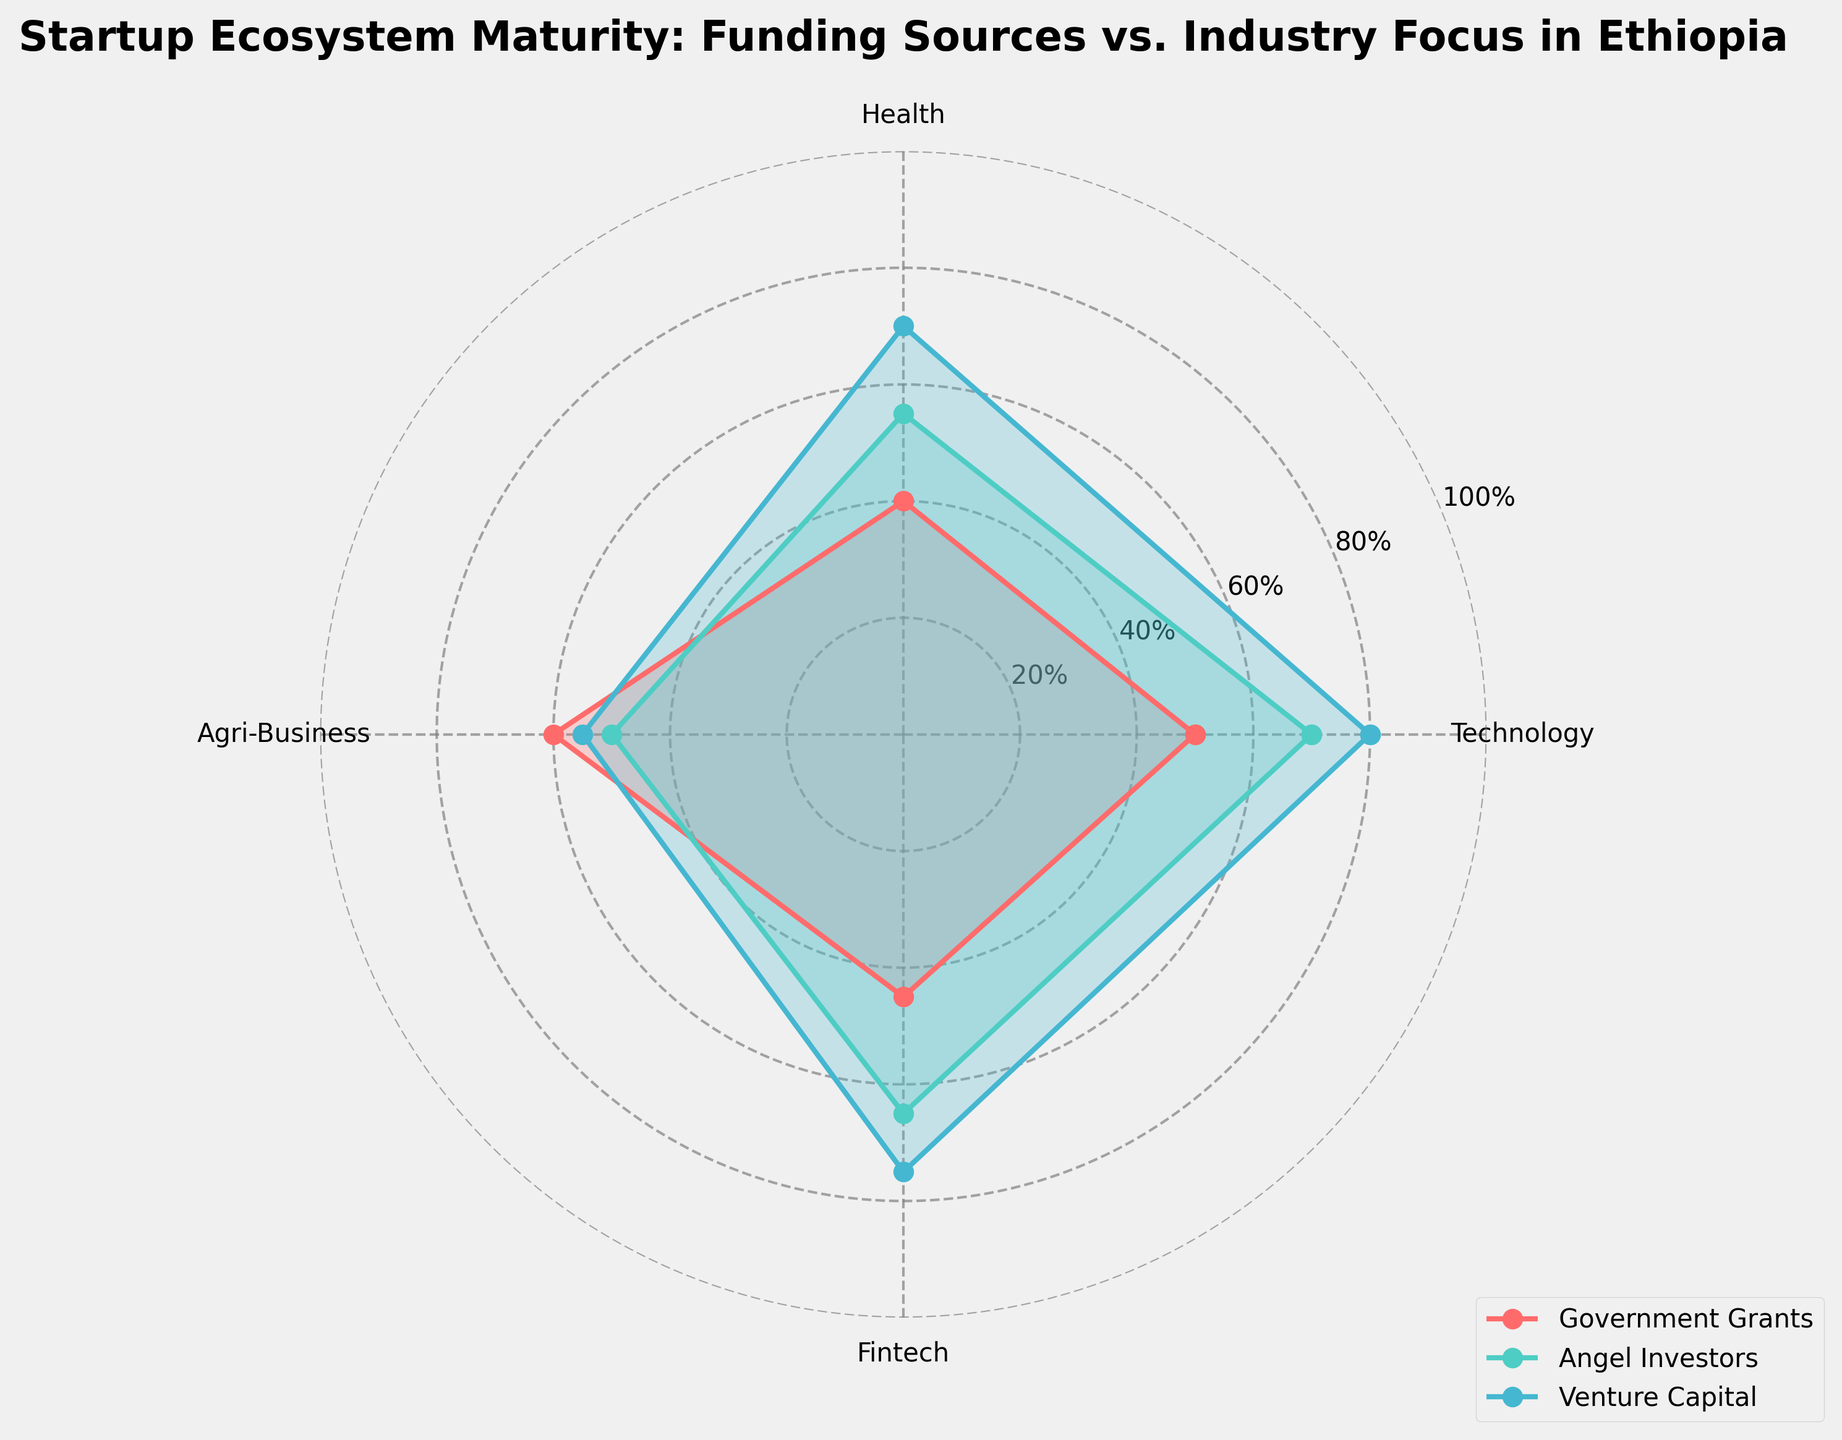What are the categories evaluated in the radar chart? The radar chart includes categories for Technology, Health, Agri-Business, and Fintech, which represent industry focuses for startup ecosystems in Ethiopia.
Answer: Technology, Health, Agri-Business, Fintech What funding sources have been plotted on the radar chart? The radar chart shows Government Grants, Angel Investors, and Venture Capital, as the funding sources analyzed.
Answer: Government Grants, Angel Investors, Venture Capital Which funding source has the highest focus on Fintech? By looking at the radar chart, Venture Capital has the highest value for Fintech, as indicated by the data point reaching the maximum apex on the Fintech axis.
Answer: Venture Capital What is the difference between the Agri-Business focus of Government Grants and Angel Investors? Government Grants have a value of 60 in Agri-Business, while Angel Investors have a value of 50. The difference is calculated as 60 - 50 = 10.
Answer: 10 Which category has the least variation in focus among the funding sources? By comparing the extent of the data points for each category across all funding sources, Health displays relatively close values of 40, 55, and 70.
Answer: Health Among the selected funding sources, which one has the most balanced focus across all categories? By visually inspecting the plot, Government Grants have values (50, 40, 60, 45), showing a more balanced distribution compared to higher variances in Angel Investors and Venture Capital.
Answer: Government Grants How does the Health focus of Venture Capital compare to that of Government Grants? Venture Capital has a higher focus on Health (70) compared to Government Grants (40). This difference is 70 - 40 = 30.
Answer: 30 What is the average focus of Angel Investors across all categories? Calculating the average, Angel Investors have values of 70, 55, 50, and 65 across categories. The average is (70 + 55 + 50 + 65) / 4 = 60.
Answer: 60 What is the sum of the Technology focus values across all funding sources? The Technology values are 50 for Government Grants, 70 for Angel Investors, and 80 for Venture Capital. The sum is 50 + 70 + 80 = 200.
Answer: 200 Which industry category does Government Grants focus on the most? According to the radar chart, Government Grants have the highest value on Agri-Business, with a value of 60.
Answer: Agri-Business 